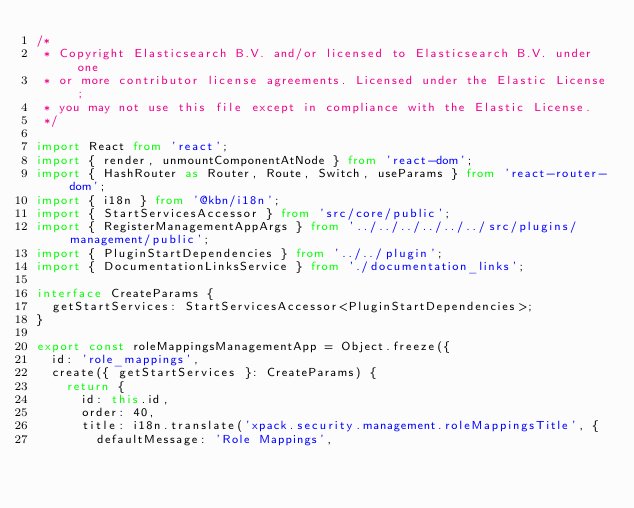Convert code to text. <code><loc_0><loc_0><loc_500><loc_500><_TypeScript_>/*
 * Copyright Elasticsearch B.V. and/or licensed to Elasticsearch B.V. under one
 * or more contributor license agreements. Licensed under the Elastic License;
 * you may not use this file except in compliance with the Elastic License.
 */

import React from 'react';
import { render, unmountComponentAtNode } from 'react-dom';
import { HashRouter as Router, Route, Switch, useParams } from 'react-router-dom';
import { i18n } from '@kbn/i18n';
import { StartServicesAccessor } from 'src/core/public';
import { RegisterManagementAppArgs } from '../../../../../../src/plugins/management/public';
import { PluginStartDependencies } from '../../plugin';
import { DocumentationLinksService } from './documentation_links';

interface CreateParams {
  getStartServices: StartServicesAccessor<PluginStartDependencies>;
}

export const roleMappingsManagementApp = Object.freeze({
  id: 'role_mappings',
  create({ getStartServices }: CreateParams) {
    return {
      id: this.id,
      order: 40,
      title: i18n.translate('xpack.security.management.roleMappingsTitle', {
        defaultMessage: 'Role Mappings',</code> 